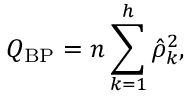Convert formula to latex. <formula><loc_0><loc_0><loc_500><loc_500>Q _ { B P } = n \sum _ { k = 1 } ^ { h } { \hat { \rho } } _ { k } ^ { 2 } ,</formula> 